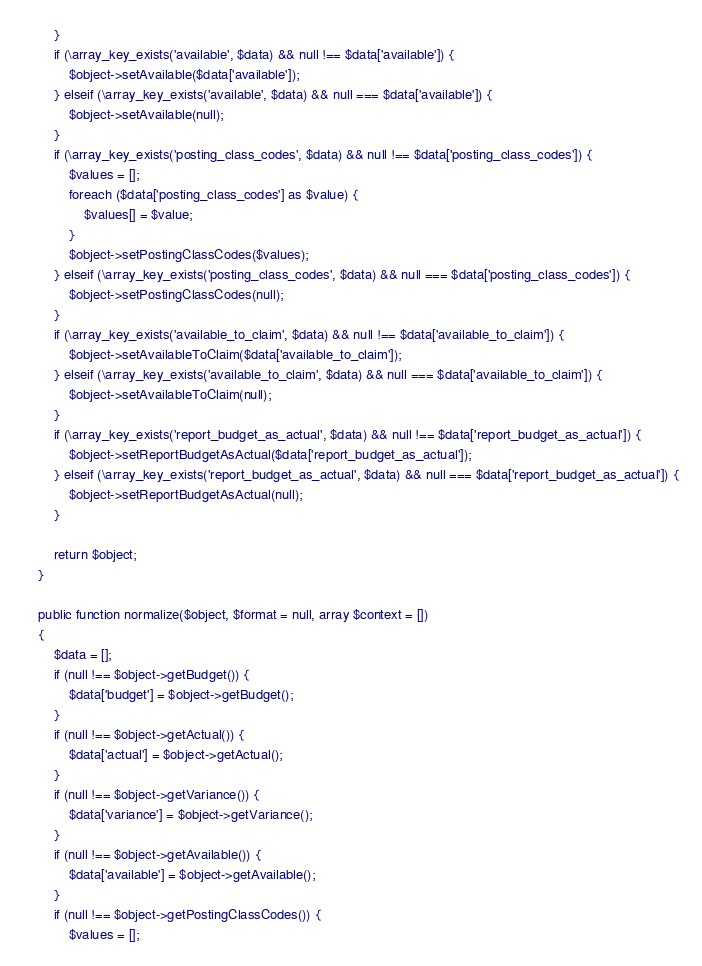Convert code to text. <code><loc_0><loc_0><loc_500><loc_500><_PHP_>		}
		if (\array_key_exists('available', $data) && null !== $data['available']) {
			$object->setAvailable($data['available']);
		} elseif (\array_key_exists('available', $data) && null === $data['available']) {
			$object->setAvailable(null);
		}
		if (\array_key_exists('posting_class_codes', $data) && null !== $data['posting_class_codes']) {
			$values = [];
			foreach ($data['posting_class_codes'] as $value) {
				$values[] = $value;
			}
			$object->setPostingClassCodes($values);
		} elseif (\array_key_exists('posting_class_codes', $data) && null === $data['posting_class_codes']) {
			$object->setPostingClassCodes(null);
		}
		if (\array_key_exists('available_to_claim', $data) && null !== $data['available_to_claim']) {
			$object->setAvailableToClaim($data['available_to_claim']);
		} elseif (\array_key_exists('available_to_claim', $data) && null === $data['available_to_claim']) {
			$object->setAvailableToClaim(null);
		}
		if (\array_key_exists('report_budget_as_actual', $data) && null !== $data['report_budget_as_actual']) {
			$object->setReportBudgetAsActual($data['report_budget_as_actual']);
		} elseif (\array_key_exists('report_budget_as_actual', $data) && null === $data['report_budget_as_actual']) {
			$object->setReportBudgetAsActual(null);
		}

		return $object;
	}

	public function normalize($object, $format = null, array $context = [])
	{
		$data = [];
		if (null !== $object->getBudget()) {
			$data['budget'] = $object->getBudget();
		}
		if (null !== $object->getActual()) {
			$data['actual'] = $object->getActual();
		}
		if (null !== $object->getVariance()) {
			$data['variance'] = $object->getVariance();
		}
		if (null !== $object->getAvailable()) {
			$data['available'] = $object->getAvailable();
		}
		if (null !== $object->getPostingClassCodes()) {
			$values = [];</code> 